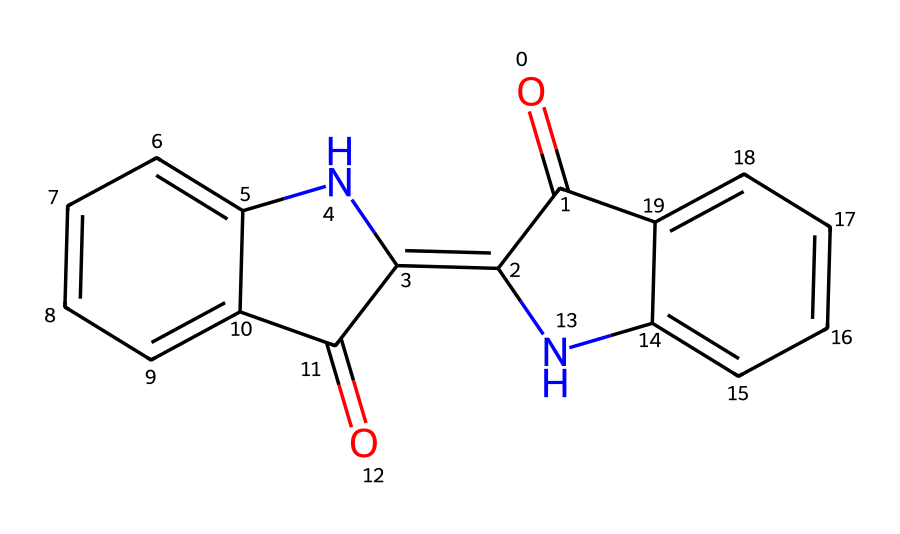How many rings are present in the structure? The structure contains three distinct ring systems, identified by the cyclical nature of the bonds connecting the atoms. Each ring is formed by a closed loop of atoms.
Answer: three What type of functional groups are present? The structure includes carbonyl groups (C=O) and amine groups (N-H). These functional groups are identifiable by their specific atom arrangements within the structure.
Answer: carbonyl and amine How many double bonds are present in the structure? By examining the structure, there are four double bonds indicated by the "=" signs connecting carbon atoms and other atoms in the rings.
Answer: four What is the molecular formula corresponding to this SMILES? By translating the SMILES notation into a chemical formula, we count the atoms: C, H, N, and O. The resulting molecular formula is derived from the connectivity and quantity of each atom.
Answer: C16H12N2O2 Does this compound exhibit geometric isomerism? The presence of rigid double bonds and the arrangement of atoms suggest potential for geometric isomerism, particularly in the rings where substituents can create different spatial orientations.
Answer: yes 